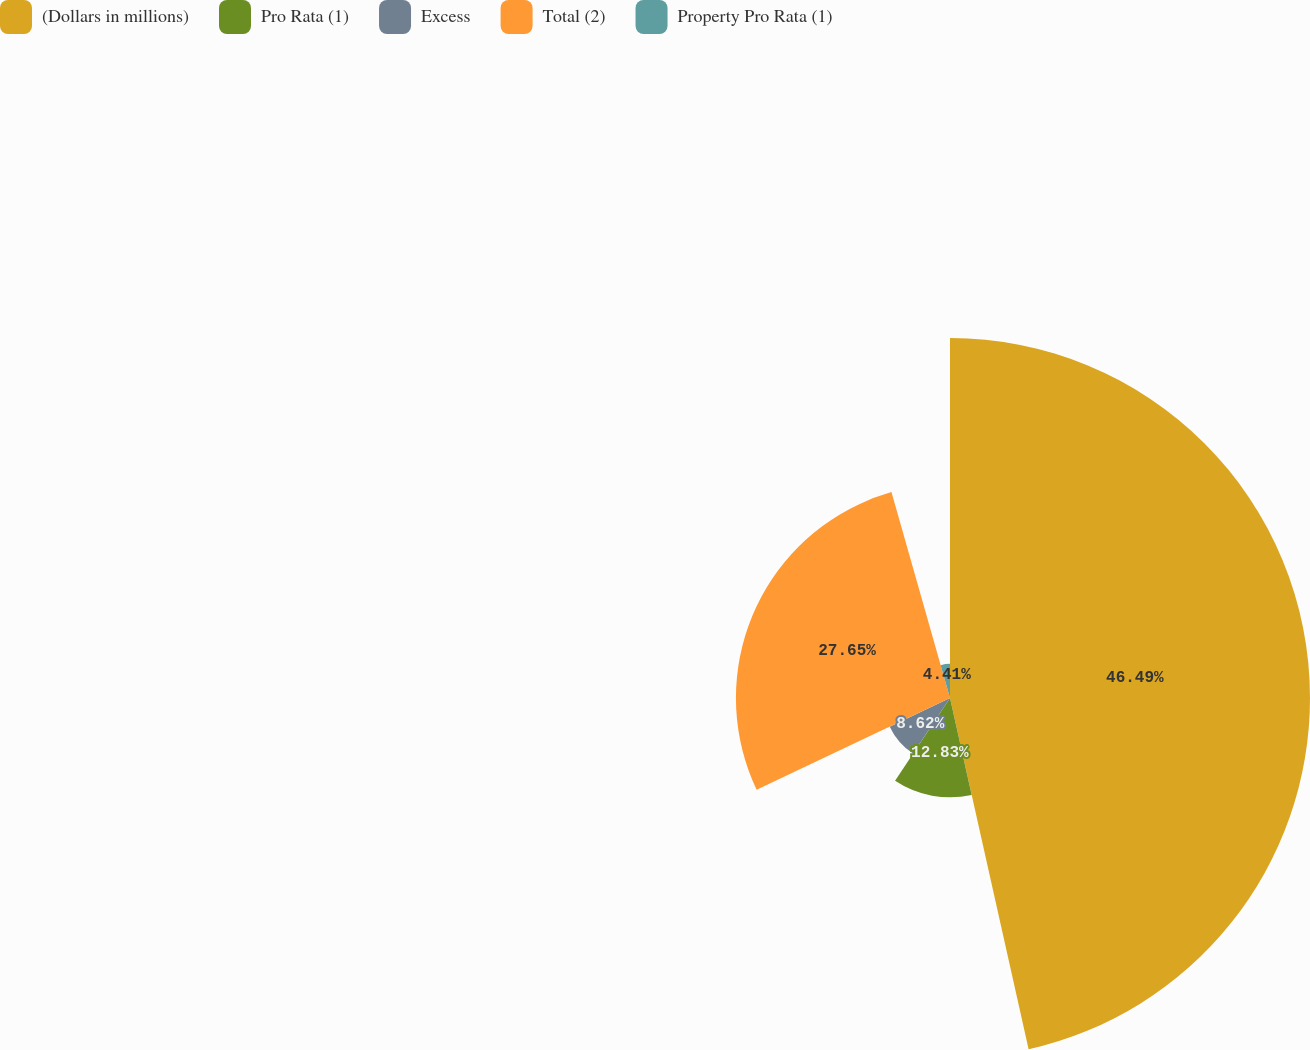<chart> <loc_0><loc_0><loc_500><loc_500><pie_chart><fcel>(Dollars in millions)<fcel>Pro Rata (1)<fcel>Excess<fcel>Total (2)<fcel>Property Pro Rata (1)<nl><fcel>46.5%<fcel>12.83%<fcel>8.62%<fcel>27.65%<fcel>4.41%<nl></chart> 